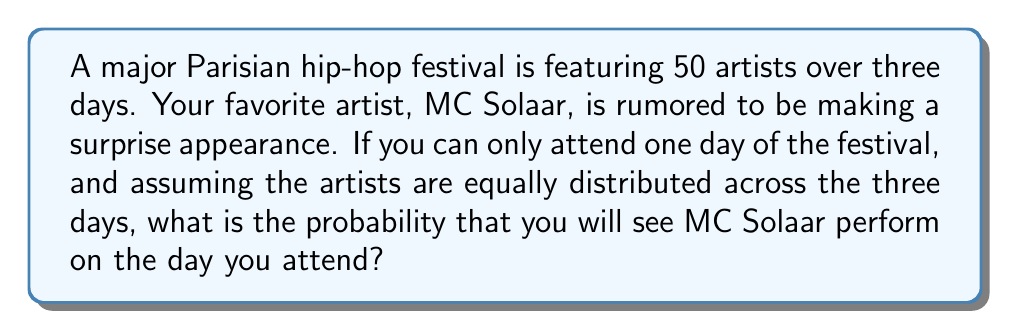Provide a solution to this math problem. Let's approach this step-by-step:

1) First, we need to determine how many artists perform each day:
   $$ \text{Artists per day} = \frac{\text{Total artists}}{\text{Number of days}} = \frac{50}{3} \approx 16.67 $$
   We'll round up to 17 artists per day, as partial performances are unlikely.

2) Now, let's consider the probability of MC Solaar performing on any given day:
   $$ P(\text{MC Solaar on a specific day}) = \frac{\text{Days MC Solaar performs}}{\text{Total festival days}} = \frac{1}{3} $$

3) This is because if MC Solaar is making only one appearance, it could be on any of the three days with equal probability.

4) Therefore, the probability of seeing MC Solaar on the day you attend is equal to the probability of him performing on that specific day, which we calculated in step 2.

5) We can express this formally as:
   $$ P(\text{Seeing MC Solaar}) = \frac{1}{3} \approx 0.3333 $$

6) To convert to a percentage: $\frac{1}{3} \times 100\% \approx 33.33\%$
Answer: $\frac{1}{3}$ or approximately 33.33% 